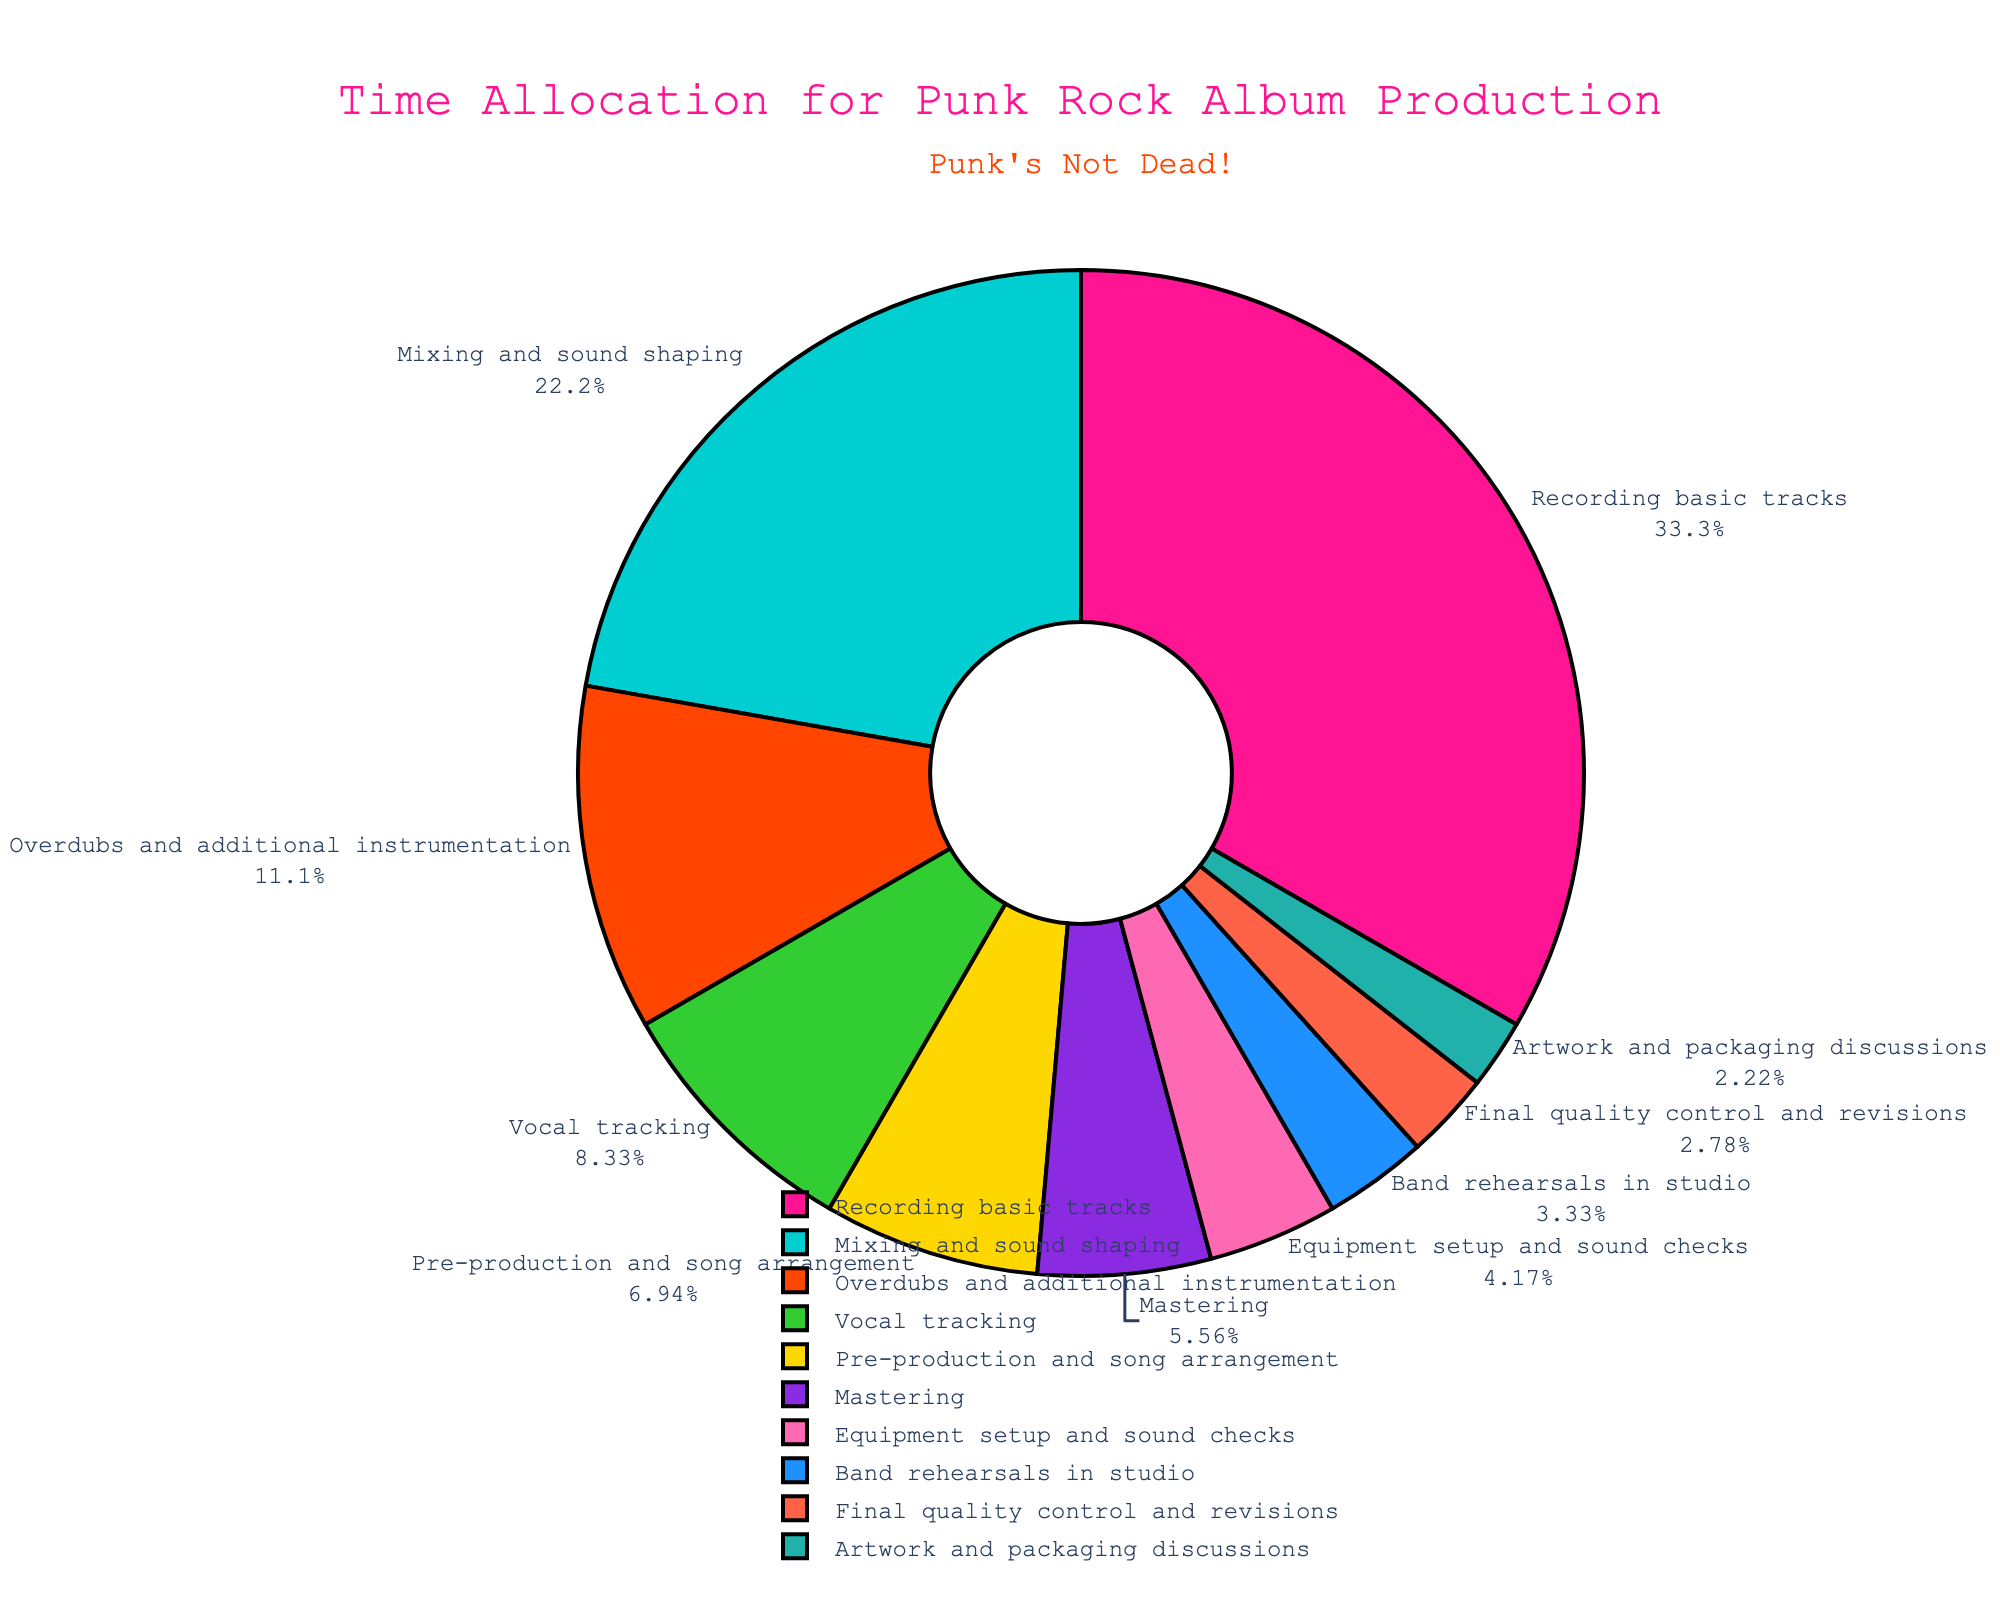Which stage uses the most time in the production process? The "Recording basic tracks" stage constitutes the highest percentage of time allocation, as evident from its largest section in the pie chart.
Answer: Recording basic tracks What stage involves more hours, Mixing and sound shaping, or Vocal tracking? By comparing their respective slices in the pie chart, the "Mixing and sound shaping" stage has a larger section than the "Vocal tracking" stage. This indicates that more hours are spent on mixing and sound shaping than on vocal tracking.
Answer: Mixing and sound shaping What percentage of time is spent on Mastering compared to the total production time? According to the pie chart, the slice representing "Mastering" provides its percentage directly. This percentage can be estimated from the section encompassing "Mastering."
Answer: 6.67% How many hours in total are spent on both Band rehearsals in the studio and Final quality control and revisions combined? Adding the hours for "Band rehearsals in the studio" (12 hours) and "Final quality control and revisions" (10 hours) results in 22 hours.
Answer: 22 hours Which stage takes less time: Equipment setup and sound checks or Artwork and packaging discussions? The pie chart visually indicates that the section for "Artwork and packaging discussions" is smaller than for "Equipment setup and sound checks." Thus, less time is spent on Artwork and packaging discussions.
Answer: Artwork and packaging discussions What is the combined percentage of time spent on Overdubs and additional instrumentation and Pre-production and song arrangement? Summing the percentages of "Overdubs and additional instrumentation" (13.33%) and "Pre-production and song arrangement" (8.33%) yields a combined percentage of 21.66%.
Answer: 21.66% If the total production time was reduced by 10 hours, which stage would still demonstrate the highest proportion of time allocation? Even with a reduction of 10 hours, the relative proportions would remain unchanged since all stages experience proportionally scaled reductions. "Recording basic tracks" would still dominate.
Answer: Recording basic tracks What is the difference in hours between the stage that employs the most time and the stage that employs the least time? Calculating the difference between "Recording basic tracks" (120 hours) and "Artwork and packaging discussions" (8 hours) results in a difference of 112 hours.
Answer: 112 hours 